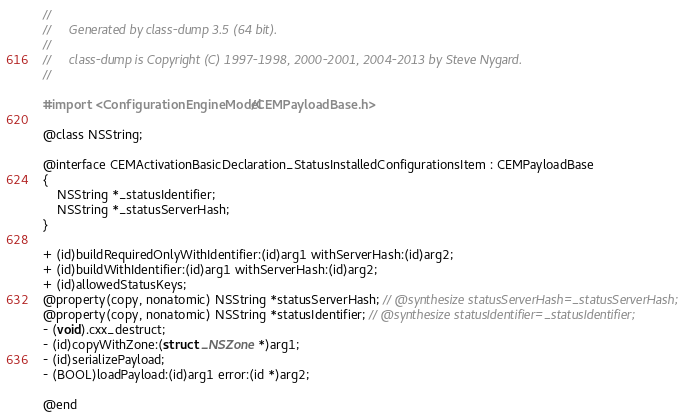<code> <loc_0><loc_0><loc_500><loc_500><_C_>//
//     Generated by class-dump 3.5 (64 bit).
//
//     class-dump is Copyright (C) 1997-1998, 2000-2001, 2004-2013 by Steve Nygard.
//

#import <ConfigurationEngineModel/CEMPayloadBase.h>

@class NSString;

@interface CEMActivationBasicDeclaration_StatusInstalledConfigurationsItem : CEMPayloadBase
{
    NSString *_statusIdentifier;
    NSString *_statusServerHash;
}

+ (id)buildRequiredOnlyWithIdentifier:(id)arg1 withServerHash:(id)arg2;
+ (id)buildWithIdentifier:(id)arg1 withServerHash:(id)arg2;
+ (id)allowedStatusKeys;
@property(copy, nonatomic) NSString *statusServerHash; // @synthesize statusServerHash=_statusServerHash;
@property(copy, nonatomic) NSString *statusIdentifier; // @synthesize statusIdentifier=_statusIdentifier;
- (void).cxx_destruct;
- (id)copyWithZone:(struct _NSZone *)arg1;
- (id)serializePayload;
- (BOOL)loadPayload:(id)arg1 error:(id *)arg2;

@end

</code> 